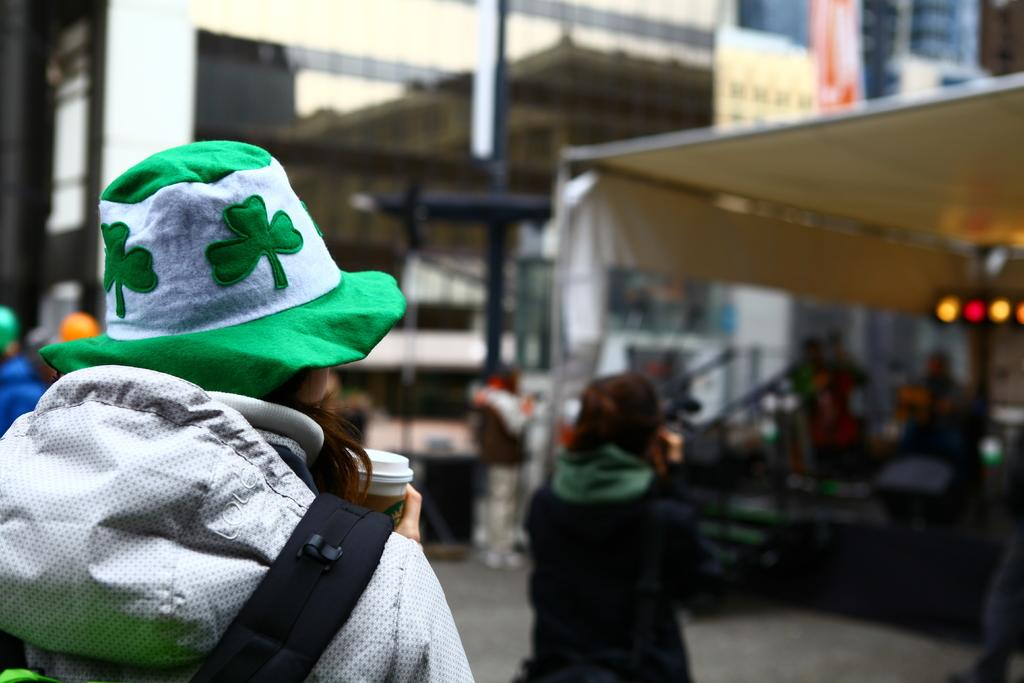What is the person in the image doing? The person is holding a coffee cup. In which direction is the person facing? The person is turning towards the back. What can be seen in the background of the image? There are buildings visible in the image. How many other people are present in the image? There are many other people in the image. What color is the bee flying around the person's shirt in the image? There is no bee present in the image, and the person's shirt is not mentioned in the facts provided. 